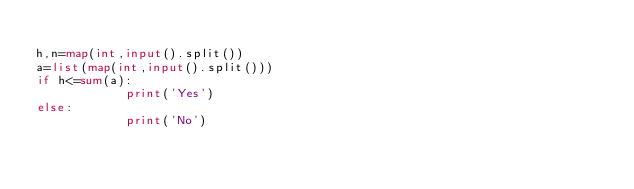Convert code to text. <code><loc_0><loc_0><loc_500><loc_500><_Python_>
h,n=map(int,input().split())
a=list(map(int,input().split()))
if h<=sum(a):
            print('Yes')
else:
            print('No')
</code> 